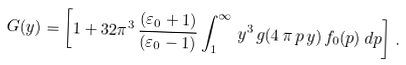Convert formula to latex. <formula><loc_0><loc_0><loc_500><loc_500>G ( y ) = \left [ 1 + 3 2 \pi ^ { 3 } \, \frac { ( \varepsilon _ { 0 } + 1 ) } { ( \varepsilon _ { 0 } - 1 ) } \int _ { 1 } ^ { \infty } \, y ^ { 3 } \, g ( 4 \, \pi \, p \, y ) \, f _ { 0 } ( p ) \, d p \right ] \, .</formula> 